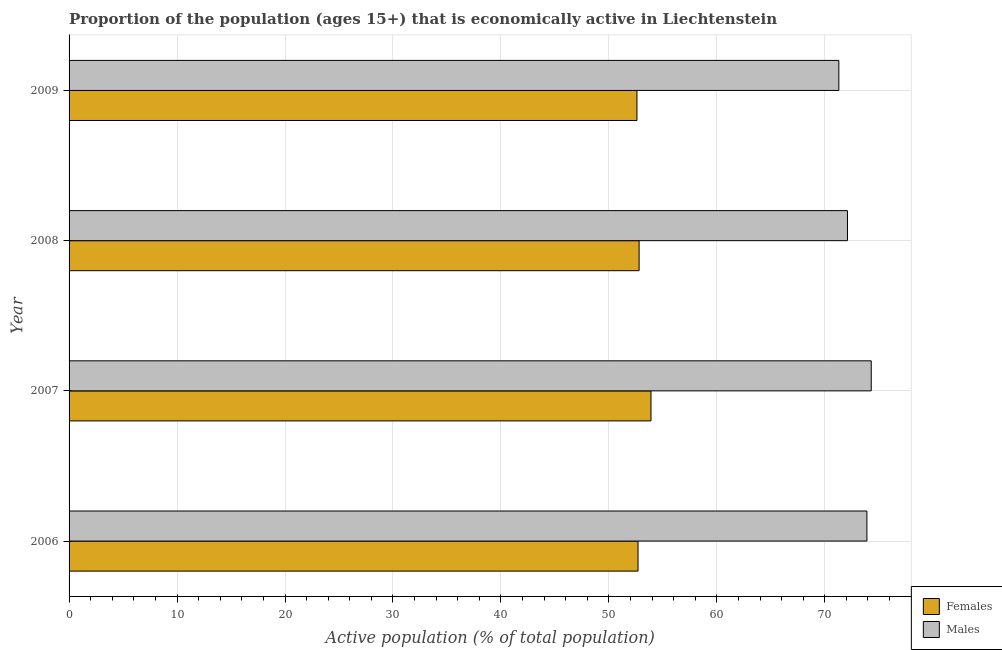Are the number of bars per tick equal to the number of legend labels?
Give a very brief answer. Yes. How many bars are there on the 4th tick from the top?
Provide a succinct answer. 2. What is the percentage of economically active male population in 2006?
Keep it short and to the point. 73.9. Across all years, what is the maximum percentage of economically active female population?
Ensure brevity in your answer.  53.9. Across all years, what is the minimum percentage of economically active female population?
Offer a terse response. 52.6. What is the total percentage of economically active male population in the graph?
Your answer should be compact. 291.6. What is the difference between the percentage of economically active female population in 2006 and the percentage of economically active male population in 2007?
Make the answer very short. -21.6. What is the average percentage of economically active male population per year?
Provide a short and direct response. 72.9. In the year 2006, what is the difference between the percentage of economically active female population and percentage of economically active male population?
Offer a very short reply. -21.2. In how many years, is the percentage of economically active male population greater than 22 %?
Your answer should be compact. 4. What is the ratio of the percentage of economically active female population in 2006 to that in 2009?
Offer a very short reply. 1. Is the percentage of economically active female population in 2006 less than that in 2008?
Your response must be concise. Yes. What is the difference between the highest and the second highest percentage of economically active male population?
Provide a succinct answer. 0.4. What is the difference between the highest and the lowest percentage of economically active male population?
Provide a succinct answer. 3. In how many years, is the percentage of economically active male population greater than the average percentage of economically active male population taken over all years?
Your answer should be compact. 2. Is the sum of the percentage of economically active female population in 2006 and 2007 greater than the maximum percentage of economically active male population across all years?
Keep it short and to the point. Yes. What does the 1st bar from the top in 2007 represents?
Your answer should be very brief. Males. What does the 2nd bar from the bottom in 2008 represents?
Your response must be concise. Males. How many bars are there?
Your answer should be very brief. 8. Are all the bars in the graph horizontal?
Make the answer very short. Yes. How many years are there in the graph?
Give a very brief answer. 4. Where does the legend appear in the graph?
Your response must be concise. Bottom right. What is the title of the graph?
Keep it short and to the point. Proportion of the population (ages 15+) that is economically active in Liechtenstein. Does "Exports" appear as one of the legend labels in the graph?
Provide a short and direct response. No. What is the label or title of the X-axis?
Provide a short and direct response. Active population (% of total population). What is the Active population (% of total population) in Females in 2006?
Offer a terse response. 52.7. What is the Active population (% of total population) of Males in 2006?
Make the answer very short. 73.9. What is the Active population (% of total population) in Females in 2007?
Make the answer very short. 53.9. What is the Active population (% of total population) of Males in 2007?
Your answer should be compact. 74.3. What is the Active population (% of total population) of Females in 2008?
Keep it short and to the point. 52.8. What is the Active population (% of total population) in Males in 2008?
Ensure brevity in your answer.  72.1. What is the Active population (% of total population) in Females in 2009?
Your answer should be very brief. 52.6. What is the Active population (% of total population) of Males in 2009?
Your response must be concise. 71.3. Across all years, what is the maximum Active population (% of total population) in Females?
Make the answer very short. 53.9. Across all years, what is the maximum Active population (% of total population) of Males?
Ensure brevity in your answer.  74.3. Across all years, what is the minimum Active population (% of total population) of Females?
Your answer should be compact. 52.6. Across all years, what is the minimum Active population (% of total population) of Males?
Offer a very short reply. 71.3. What is the total Active population (% of total population) of Females in the graph?
Give a very brief answer. 212. What is the total Active population (% of total population) of Males in the graph?
Ensure brevity in your answer.  291.6. What is the difference between the Active population (% of total population) of Females in 2006 and that in 2007?
Keep it short and to the point. -1.2. What is the difference between the Active population (% of total population) of Males in 2007 and that in 2008?
Provide a short and direct response. 2.2. What is the difference between the Active population (% of total population) of Females in 2007 and that in 2009?
Offer a terse response. 1.3. What is the difference between the Active population (% of total population) of Males in 2007 and that in 2009?
Keep it short and to the point. 3. What is the difference between the Active population (% of total population) in Females in 2006 and the Active population (% of total population) in Males in 2007?
Make the answer very short. -21.6. What is the difference between the Active population (% of total population) of Females in 2006 and the Active population (% of total population) of Males in 2008?
Your answer should be compact. -19.4. What is the difference between the Active population (% of total population) of Females in 2006 and the Active population (% of total population) of Males in 2009?
Give a very brief answer. -18.6. What is the difference between the Active population (% of total population) in Females in 2007 and the Active population (% of total population) in Males in 2008?
Your answer should be very brief. -18.2. What is the difference between the Active population (% of total population) of Females in 2007 and the Active population (% of total population) of Males in 2009?
Keep it short and to the point. -17.4. What is the difference between the Active population (% of total population) in Females in 2008 and the Active population (% of total population) in Males in 2009?
Make the answer very short. -18.5. What is the average Active population (% of total population) in Females per year?
Your answer should be very brief. 53. What is the average Active population (% of total population) of Males per year?
Provide a short and direct response. 72.9. In the year 2006, what is the difference between the Active population (% of total population) of Females and Active population (% of total population) of Males?
Provide a short and direct response. -21.2. In the year 2007, what is the difference between the Active population (% of total population) of Females and Active population (% of total population) of Males?
Give a very brief answer. -20.4. In the year 2008, what is the difference between the Active population (% of total population) in Females and Active population (% of total population) in Males?
Your answer should be very brief. -19.3. In the year 2009, what is the difference between the Active population (% of total population) in Females and Active population (% of total population) in Males?
Make the answer very short. -18.7. What is the ratio of the Active population (% of total population) in Females in 2006 to that in 2007?
Your answer should be compact. 0.98. What is the ratio of the Active population (% of total population) of Males in 2006 to that in 2008?
Ensure brevity in your answer.  1.02. What is the ratio of the Active population (% of total population) in Males in 2006 to that in 2009?
Ensure brevity in your answer.  1.04. What is the ratio of the Active population (% of total population) of Females in 2007 to that in 2008?
Give a very brief answer. 1.02. What is the ratio of the Active population (% of total population) in Males in 2007 to that in 2008?
Provide a short and direct response. 1.03. What is the ratio of the Active population (% of total population) in Females in 2007 to that in 2009?
Offer a terse response. 1.02. What is the ratio of the Active population (% of total population) in Males in 2007 to that in 2009?
Keep it short and to the point. 1.04. What is the ratio of the Active population (% of total population) of Males in 2008 to that in 2009?
Provide a succinct answer. 1.01. What is the difference between the highest and the second highest Active population (% of total population) in Males?
Your answer should be very brief. 0.4. What is the difference between the highest and the lowest Active population (% of total population) of Males?
Your answer should be compact. 3. 